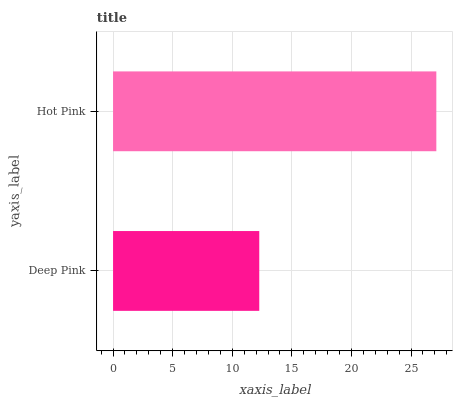Is Deep Pink the minimum?
Answer yes or no. Yes. Is Hot Pink the maximum?
Answer yes or no. Yes. Is Hot Pink the minimum?
Answer yes or no. No. Is Hot Pink greater than Deep Pink?
Answer yes or no. Yes. Is Deep Pink less than Hot Pink?
Answer yes or no. Yes. Is Deep Pink greater than Hot Pink?
Answer yes or no. No. Is Hot Pink less than Deep Pink?
Answer yes or no. No. Is Hot Pink the high median?
Answer yes or no. Yes. Is Deep Pink the low median?
Answer yes or no. Yes. Is Deep Pink the high median?
Answer yes or no. No. Is Hot Pink the low median?
Answer yes or no. No. 